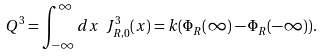Convert formula to latex. <formula><loc_0><loc_0><loc_500><loc_500>Q ^ { 3 } = \int _ { - \infty } ^ { \infty } d x \ J ^ { 3 } _ { R , 0 } ( x ) = k ( \Phi _ { R } ( \infty ) - \Phi _ { R } ( - \infty ) ) .</formula> 